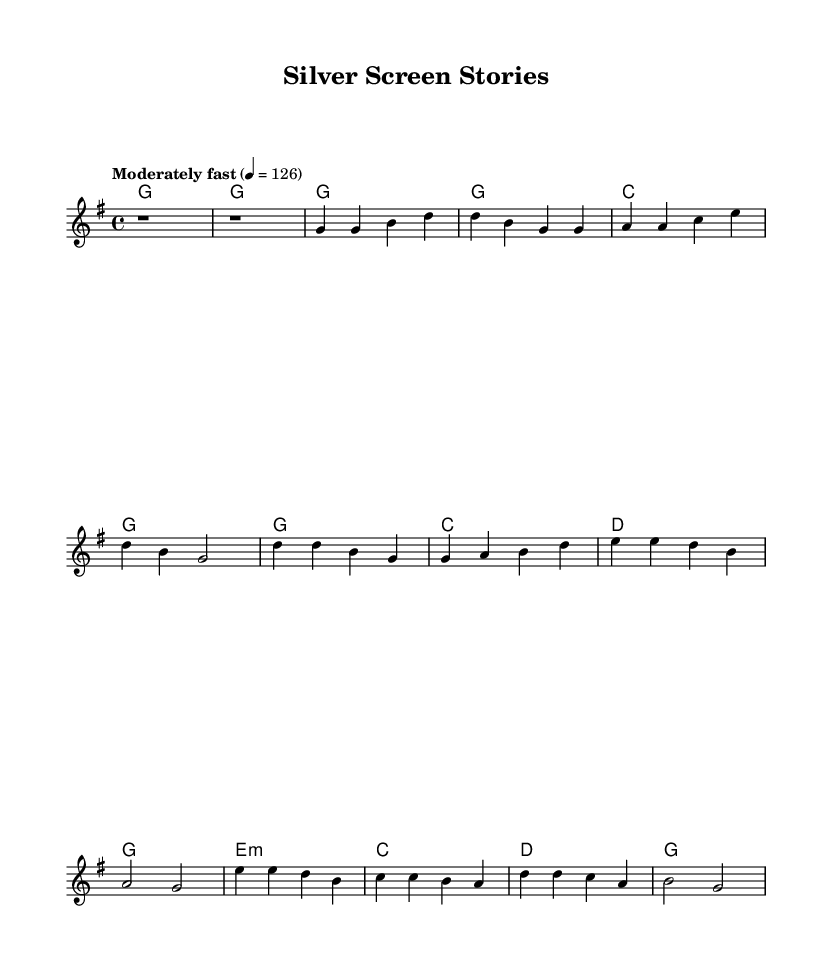What is the key signature of this music? The key signature is G major, which consists of one sharp (F#). This is determined from the global context where the key is specified.
Answer: G major What is the time signature of this piece? The time signature indicated in the global context is 4/4. This means there are four beats per measure, with a quarter note receiving one beat.
Answer: 4/4 What is the tempo marking for this music? The tempo marking is "Moderately fast" with a metronome mark of 126 beats per minute. This is noted in the global context where the tempo is specified.
Answer: Moderately fast How many measures are there in the chorus section? Analyzing the structure of the music, the chorus section consists of four measures: g4 d4 a4 g2. This can be counted directly from the melody and its corresponding lyrics section.
Answer: Four What lyrical theme is celebrated in this song? The theme revolves around storytelling through film, as evidenced by the lyrics discussing the silver screen, history, and shared humanity, which are central to both film and music narratives.
Answer: Storytelling What type of harmony is used in the bridge? The harmony in the bridge is minor, specifically e minor, which is indicated in the harmonies section where it shows "e1:m." This indicates the use of a minor chord.
Answer: Minor What does the bridge lyrics express about the song's message? The bridge lyrics convey a message of unity and understanding, focusing on shared humanity through the lens of storytelling, aligning with country rock's traditional narrative style.
Answer: Shared humanity 